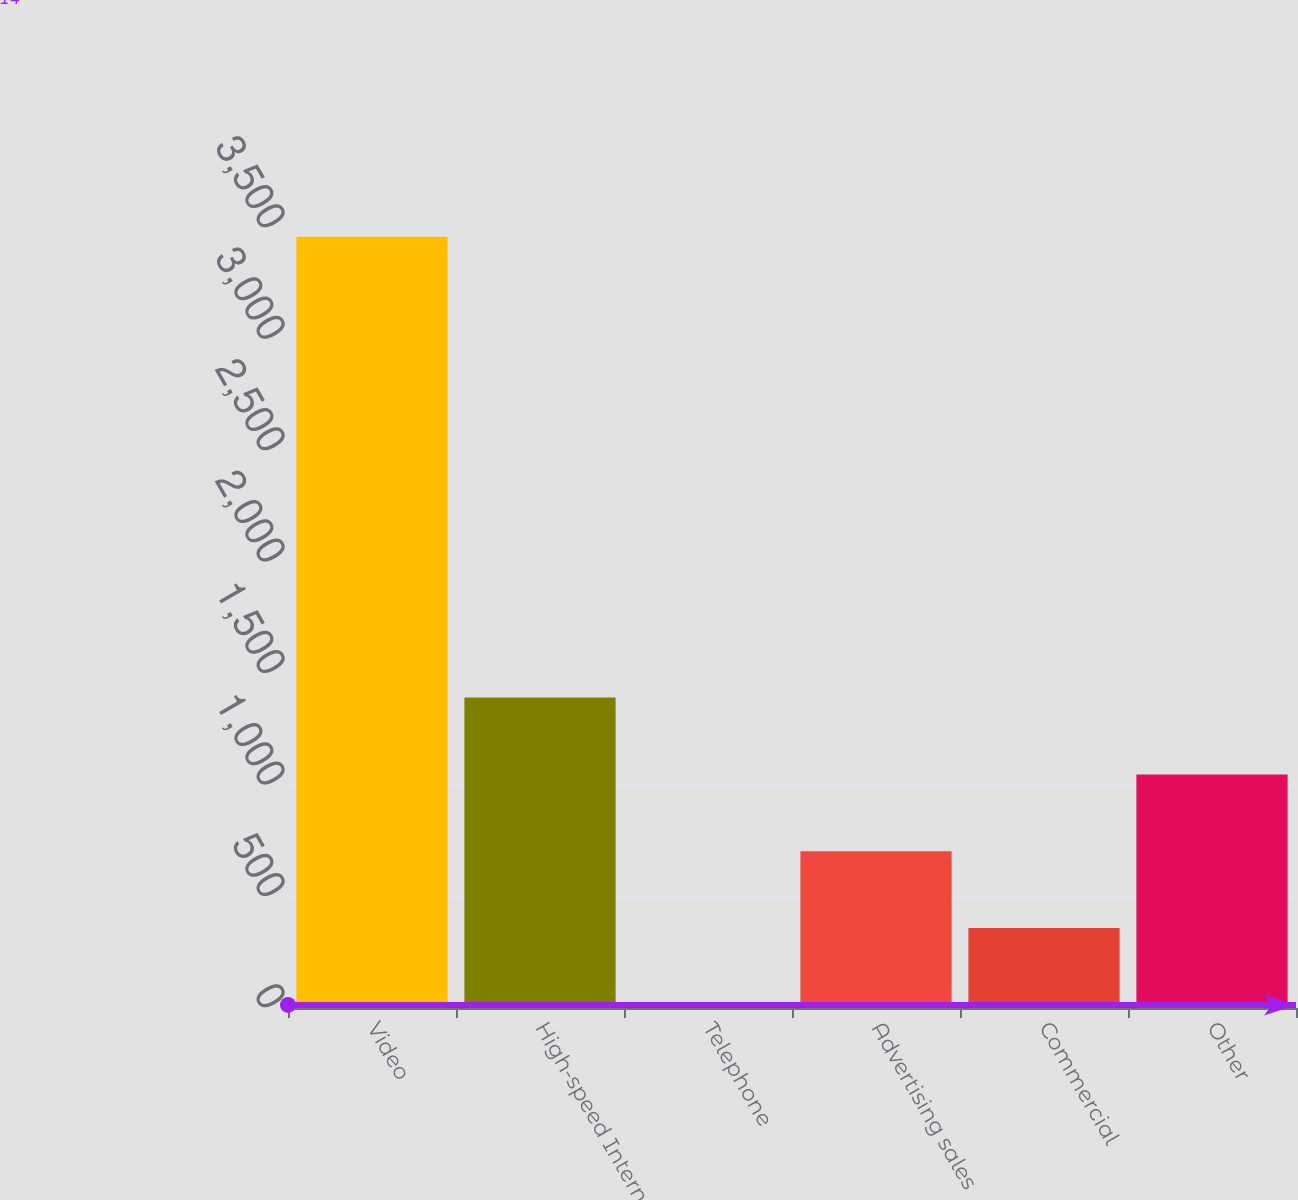Convert chart. <chart><loc_0><loc_0><loc_500><loc_500><bar_chart><fcel>Video<fcel>High-speed Internet<fcel>Telephone<fcel>Advertising sales<fcel>Commercial<fcel>Other<nl><fcel>3461<fcel>1392.8<fcel>14<fcel>703.4<fcel>358.7<fcel>1048.1<nl></chart> 